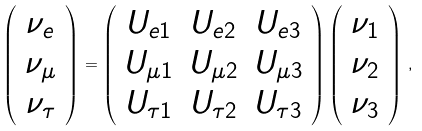Convert formula to latex. <formula><loc_0><loc_0><loc_500><loc_500>\left ( \begin{array} { c } \nu _ { e } \\ \nu _ { \mu } \\ \nu _ { \tau } \end{array} \right ) = \left ( \begin{array} { c c c } U _ { e 1 } & U _ { e 2 } & U _ { e 3 } \\ U _ { \mu 1 } & U _ { \mu 2 } & U _ { \mu 3 } \\ U _ { \tau 1 } & U _ { \tau 2 } & U _ { \tau 3 } \end{array} \right ) \left ( \begin{array} { c } \nu _ { 1 } \\ \nu _ { 2 } \\ \nu _ { 3 } \end{array} \right ) \, ,</formula> 